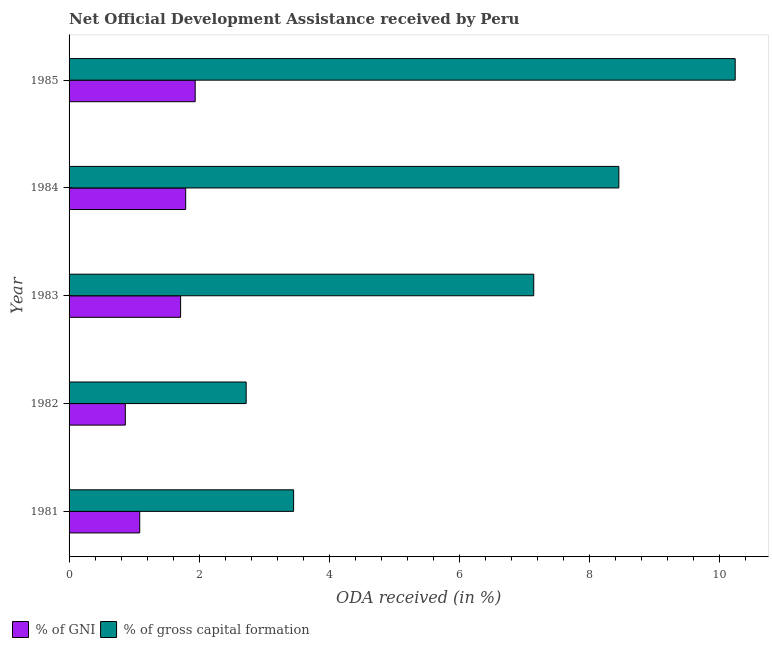How many different coloured bars are there?
Your response must be concise. 2. How many groups of bars are there?
Provide a short and direct response. 5. Are the number of bars per tick equal to the number of legend labels?
Offer a terse response. Yes. What is the label of the 5th group of bars from the top?
Provide a short and direct response. 1981. In how many cases, is the number of bars for a given year not equal to the number of legend labels?
Offer a terse response. 0. What is the oda received as percentage of gross capital formation in 1985?
Keep it short and to the point. 10.24. Across all years, what is the maximum oda received as percentage of gross capital formation?
Keep it short and to the point. 10.24. Across all years, what is the minimum oda received as percentage of gni?
Keep it short and to the point. 0.86. In which year was the oda received as percentage of gross capital formation minimum?
Make the answer very short. 1982. What is the total oda received as percentage of gross capital formation in the graph?
Provide a succinct answer. 32.01. What is the difference between the oda received as percentage of gross capital formation in 1982 and that in 1984?
Your answer should be very brief. -5.73. What is the difference between the oda received as percentage of gni in 1985 and the oda received as percentage of gross capital formation in 1984?
Ensure brevity in your answer.  -6.51. What is the average oda received as percentage of gross capital formation per year?
Your answer should be compact. 6.4. In the year 1981, what is the difference between the oda received as percentage of gni and oda received as percentage of gross capital formation?
Your answer should be very brief. -2.37. What is the ratio of the oda received as percentage of gross capital formation in 1981 to that in 1984?
Provide a short and direct response. 0.41. Is the difference between the oda received as percentage of gni in 1981 and 1984 greater than the difference between the oda received as percentage of gross capital formation in 1981 and 1984?
Offer a very short reply. Yes. What is the difference between the highest and the second highest oda received as percentage of gross capital formation?
Your answer should be very brief. 1.79. What is the difference between the highest and the lowest oda received as percentage of gross capital formation?
Your answer should be very brief. 7.52. In how many years, is the oda received as percentage of gross capital formation greater than the average oda received as percentage of gross capital formation taken over all years?
Your response must be concise. 3. Is the sum of the oda received as percentage of gross capital formation in 1981 and 1984 greater than the maximum oda received as percentage of gni across all years?
Keep it short and to the point. Yes. What does the 1st bar from the top in 1984 represents?
Give a very brief answer. % of gross capital formation. What does the 1st bar from the bottom in 1983 represents?
Make the answer very short. % of GNI. How many bars are there?
Give a very brief answer. 10. How many years are there in the graph?
Give a very brief answer. 5. What is the difference between two consecutive major ticks on the X-axis?
Make the answer very short. 2. Are the values on the major ticks of X-axis written in scientific E-notation?
Your response must be concise. No. Does the graph contain any zero values?
Your response must be concise. No. How many legend labels are there?
Make the answer very short. 2. What is the title of the graph?
Provide a succinct answer. Net Official Development Assistance received by Peru. Does "Travel services" appear as one of the legend labels in the graph?
Your answer should be very brief. No. What is the label or title of the X-axis?
Offer a very short reply. ODA received (in %). What is the label or title of the Y-axis?
Offer a terse response. Year. What is the ODA received (in %) in % of GNI in 1981?
Your answer should be compact. 1.09. What is the ODA received (in %) of % of gross capital formation in 1981?
Your answer should be compact. 3.45. What is the ODA received (in %) of % of GNI in 1982?
Offer a terse response. 0.86. What is the ODA received (in %) of % of gross capital formation in 1982?
Offer a very short reply. 2.72. What is the ODA received (in %) of % of GNI in 1983?
Your response must be concise. 1.71. What is the ODA received (in %) of % of gross capital formation in 1983?
Your answer should be very brief. 7.14. What is the ODA received (in %) in % of GNI in 1984?
Your response must be concise. 1.79. What is the ODA received (in %) in % of gross capital formation in 1984?
Your answer should be compact. 8.45. What is the ODA received (in %) in % of GNI in 1985?
Offer a very short reply. 1.94. What is the ODA received (in %) of % of gross capital formation in 1985?
Provide a short and direct response. 10.24. Across all years, what is the maximum ODA received (in %) in % of GNI?
Ensure brevity in your answer.  1.94. Across all years, what is the maximum ODA received (in %) of % of gross capital formation?
Provide a succinct answer. 10.24. Across all years, what is the minimum ODA received (in %) in % of GNI?
Make the answer very short. 0.86. Across all years, what is the minimum ODA received (in %) in % of gross capital formation?
Give a very brief answer. 2.72. What is the total ODA received (in %) of % of GNI in the graph?
Ensure brevity in your answer.  7.4. What is the total ODA received (in %) in % of gross capital formation in the graph?
Make the answer very short. 32.01. What is the difference between the ODA received (in %) in % of GNI in 1981 and that in 1982?
Offer a very short reply. 0.22. What is the difference between the ODA received (in %) of % of gross capital formation in 1981 and that in 1982?
Keep it short and to the point. 0.73. What is the difference between the ODA received (in %) in % of GNI in 1981 and that in 1983?
Your answer should be compact. -0.63. What is the difference between the ODA received (in %) in % of gross capital formation in 1981 and that in 1983?
Keep it short and to the point. -3.69. What is the difference between the ODA received (in %) of % of GNI in 1981 and that in 1984?
Offer a very short reply. -0.71. What is the difference between the ODA received (in %) in % of gross capital formation in 1981 and that in 1984?
Offer a terse response. -5. What is the difference between the ODA received (in %) of % of GNI in 1981 and that in 1985?
Keep it short and to the point. -0.85. What is the difference between the ODA received (in %) in % of gross capital formation in 1981 and that in 1985?
Your response must be concise. -6.79. What is the difference between the ODA received (in %) of % of GNI in 1982 and that in 1983?
Offer a very short reply. -0.85. What is the difference between the ODA received (in %) in % of gross capital formation in 1982 and that in 1983?
Make the answer very short. -4.42. What is the difference between the ODA received (in %) of % of GNI in 1982 and that in 1984?
Your response must be concise. -0.93. What is the difference between the ODA received (in %) of % of gross capital formation in 1982 and that in 1984?
Offer a terse response. -5.73. What is the difference between the ODA received (in %) in % of GNI in 1982 and that in 1985?
Offer a very short reply. -1.07. What is the difference between the ODA received (in %) of % of gross capital formation in 1982 and that in 1985?
Give a very brief answer. -7.52. What is the difference between the ODA received (in %) of % of GNI in 1983 and that in 1984?
Your answer should be very brief. -0.08. What is the difference between the ODA received (in %) in % of gross capital formation in 1983 and that in 1984?
Keep it short and to the point. -1.31. What is the difference between the ODA received (in %) of % of GNI in 1983 and that in 1985?
Keep it short and to the point. -0.22. What is the difference between the ODA received (in %) in % of gross capital formation in 1983 and that in 1985?
Give a very brief answer. -3.1. What is the difference between the ODA received (in %) in % of GNI in 1984 and that in 1985?
Make the answer very short. -0.15. What is the difference between the ODA received (in %) of % of gross capital formation in 1984 and that in 1985?
Your answer should be very brief. -1.79. What is the difference between the ODA received (in %) in % of GNI in 1981 and the ODA received (in %) in % of gross capital formation in 1982?
Make the answer very short. -1.64. What is the difference between the ODA received (in %) of % of GNI in 1981 and the ODA received (in %) of % of gross capital formation in 1983?
Your answer should be very brief. -6.06. What is the difference between the ODA received (in %) of % of GNI in 1981 and the ODA received (in %) of % of gross capital formation in 1984?
Your answer should be compact. -7.36. What is the difference between the ODA received (in %) in % of GNI in 1981 and the ODA received (in %) in % of gross capital formation in 1985?
Offer a terse response. -9.15. What is the difference between the ODA received (in %) of % of GNI in 1982 and the ODA received (in %) of % of gross capital formation in 1983?
Give a very brief answer. -6.28. What is the difference between the ODA received (in %) of % of GNI in 1982 and the ODA received (in %) of % of gross capital formation in 1984?
Give a very brief answer. -7.59. What is the difference between the ODA received (in %) of % of GNI in 1982 and the ODA received (in %) of % of gross capital formation in 1985?
Keep it short and to the point. -9.37. What is the difference between the ODA received (in %) of % of GNI in 1983 and the ODA received (in %) of % of gross capital formation in 1984?
Provide a succinct answer. -6.74. What is the difference between the ODA received (in %) in % of GNI in 1983 and the ODA received (in %) in % of gross capital formation in 1985?
Provide a succinct answer. -8.52. What is the difference between the ODA received (in %) of % of GNI in 1984 and the ODA received (in %) of % of gross capital formation in 1985?
Offer a terse response. -8.45. What is the average ODA received (in %) of % of GNI per year?
Ensure brevity in your answer.  1.48. What is the average ODA received (in %) in % of gross capital formation per year?
Keep it short and to the point. 6.4. In the year 1981, what is the difference between the ODA received (in %) of % of GNI and ODA received (in %) of % of gross capital formation?
Make the answer very short. -2.37. In the year 1982, what is the difference between the ODA received (in %) in % of GNI and ODA received (in %) in % of gross capital formation?
Make the answer very short. -1.86. In the year 1983, what is the difference between the ODA received (in %) of % of GNI and ODA received (in %) of % of gross capital formation?
Your answer should be very brief. -5.43. In the year 1984, what is the difference between the ODA received (in %) in % of GNI and ODA received (in %) in % of gross capital formation?
Your response must be concise. -6.66. In the year 1985, what is the difference between the ODA received (in %) of % of GNI and ODA received (in %) of % of gross capital formation?
Provide a succinct answer. -8.3. What is the ratio of the ODA received (in %) of % of GNI in 1981 to that in 1982?
Provide a short and direct response. 1.26. What is the ratio of the ODA received (in %) of % of gross capital formation in 1981 to that in 1982?
Provide a succinct answer. 1.27. What is the ratio of the ODA received (in %) of % of GNI in 1981 to that in 1983?
Your answer should be very brief. 0.63. What is the ratio of the ODA received (in %) of % of gross capital formation in 1981 to that in 1983?
Make the answer very short. 0.48. What is the ratio of the ODA received (in %) in % of GNI in 1981 to that in 1984?
Provide a succinct answer. 0.61. What is the ratio of the ODA received (in %) in % of gross capital formation in 1981 to that in 1984?
Your answer should be very brief. 0.41. What is the ratio of the ODA received (in %) in % of GNI in 1981 to that in 1985?
Provide a short and direct response. 0.56. What is the ratio of the ODA received (in %) in % of gross capital formation in 1981 to that in 1985?
Offer a terse response. 0.34. What is the ratio of the ODA received (in %) of % of GNI in 1982 to that in 1983?
Provide a short and direct response. 0.5. What is the ratio of the ODA received (in %) of % of gross capital formation in 1982 to that in 1983?
Offer a terse response. 0.38. What is the ratio of the ODA received (in %) of % of GNI in 1982 to that in 1984?
Ensure brevity in your answer.  0.48. What is the ratio of the ODA received (in %) of % of gross capital formation in 1982 to that in 1984?
Your response must be concise. 0.32. What is the ratio of the ODA received (in %) of % of GNI in 1982 to that in 1985?
Offer a terse response. 0.45. What is the ratio of the ODA received (in %) of % of gross capital formation in 1982 to that in 1985?
Offer a very short reply. 0.27. What is the ratio of the ODA received (in %) of % of GNI in 1983 to that in 1984?
Provide a succinct answer. 0.96. What is the ratio of the ODA received (in %) in % of gross capital formation in 1983 to that in 1984?
Offer a terse response. 0.85. What is the ratio of the ODA received (in %) of % of GNI in 1983 to that in 1985?
Your answer should be compact. 0.88. What is the ratio of the ODA received (in %) in % of gross capital formation in 1983 to that in 1985?
Your answer should be compact. 0.7. What is the ratio of the ODA received (in %) in % of GNI in 1984 to that in 1985?
Keep it short and to the point. 0.92. What is the ratio of the ODA received (in %) in % of gross capital formation in 1984 to that in 1985?
Your response must be concise. 0.83. What is the difference between the highest and the second highest ODA received (in %) in % of GNI?
Offer a terse response. 0.15. What is the difference between the highest and the second highest ODA received (in %) of % of gross capital formation?
Keep it short and to the point. 1.79. What is the difference between the highest and the lowest ODA received (in %) of % of GNI?
Your answer should be compact. 1.07. What is the difference between the highest and the lowest ODA received (in %) of % of gross capital formation?
Give a very brief answer. 7.52. 